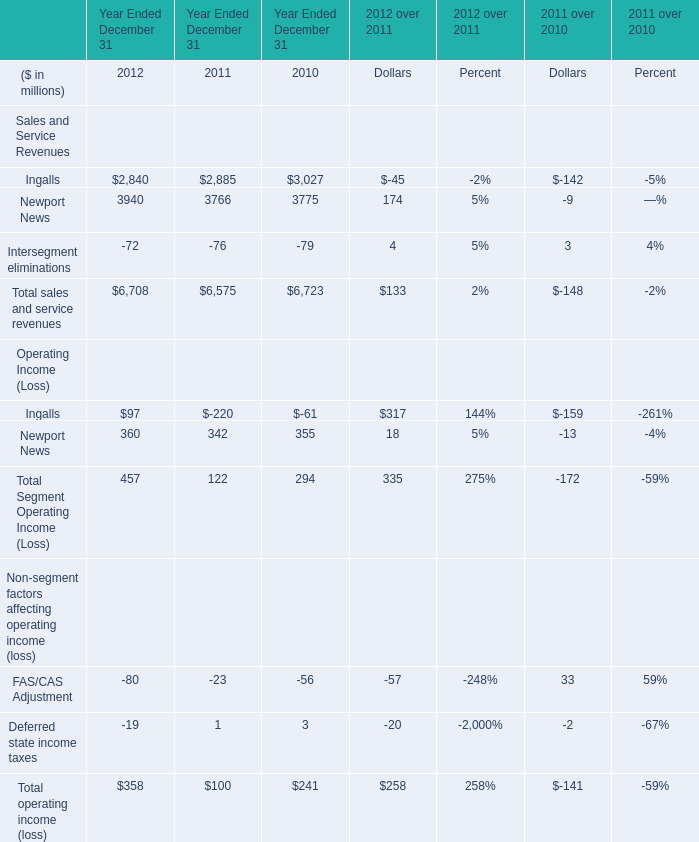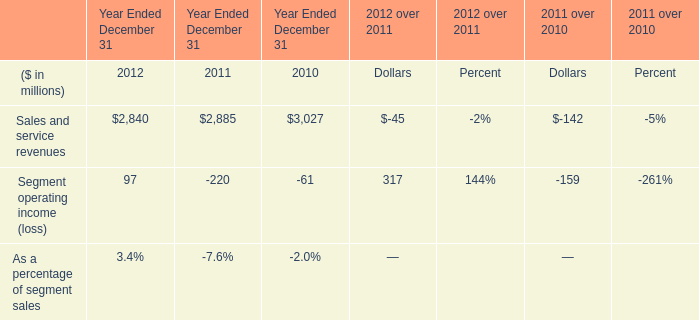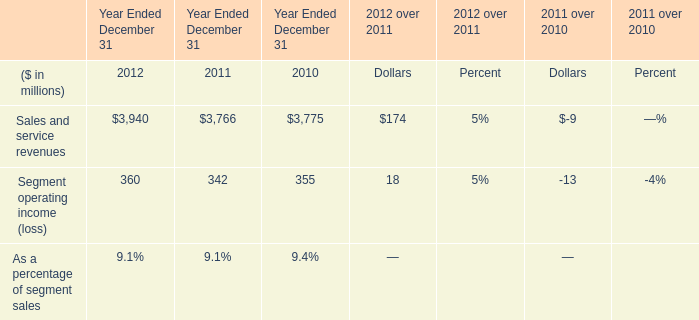wha is the percentage change in the valuation allowance from 2011 to 2012? 
Computations: ((21 - 18) / 18)
Answer: 0.16667. 